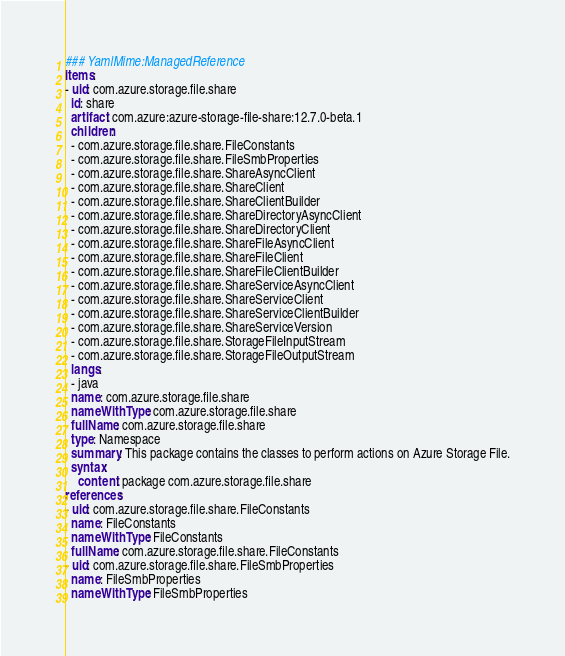<code> <loc_0><loc_0><loc_500><loc_500><_YAML_>### YamlMime:ManagedReference
items:
- uid: com.azure.storage.file.share
  id: share
  artifact: com.azure:azure-storage-file-share:12.7.0-beta.1
  children:
  - com.azure.storage.file.share.FileConstants
  - com.azure.storage.file.share.FileSmbProperties
  - com.azure.storage.file.share.ShareAsyncClient
  - com.azure.storage.file.share.ShareClient
  - com.azure.storage.file.share.ShareClientBuilder
  - com.azure.storage.file.share.ShareDirectoryAsyncClient
  - com.azure.storage.file.share.ShareDirectoryClient
  - com.azure.storage.file.share.ShareFileAsyncClient
  - com.azure.storage.file.share.ShareFileClient
  - com.azure.storage.file.share.ShareFileClientBuilder
  - com.azure.storage.file.share.ShareServiceAsyncClient
  - com.azure.storage.file.share.ShareServiceClient
  - com.azure.storage.file.share.ShareServiceClientBuilder
  - com.azure.storage.file.share.ShareServiceVersion
  - com.azure.storage.file.share.StorageFileInputStream
  - com.azure.storage.file.share.StorageFileOutputStream
  langs:
  - java
  name: com.azure.storage.file.share
  nameWithType: com.azure.storage.file.share
  fullName: com.azure.storage.file.share
  type: Namespace
  summary: This package contains the classes to perform actions on Azure Storage File.
  syntax:
    content: package com.azure.storage.file.share
references:
- uid: com.azure.storage.file.share.FileConstants
  name: FileConstants
  nameWithType: FileConstants
  fullName: com.azure.storage.file.share.FileConstants
- uid: com.azure.storage.file.share.FileSmbProperties
  name: FileSmbProperties
  nameWithType: FileSmbProperties</code> 